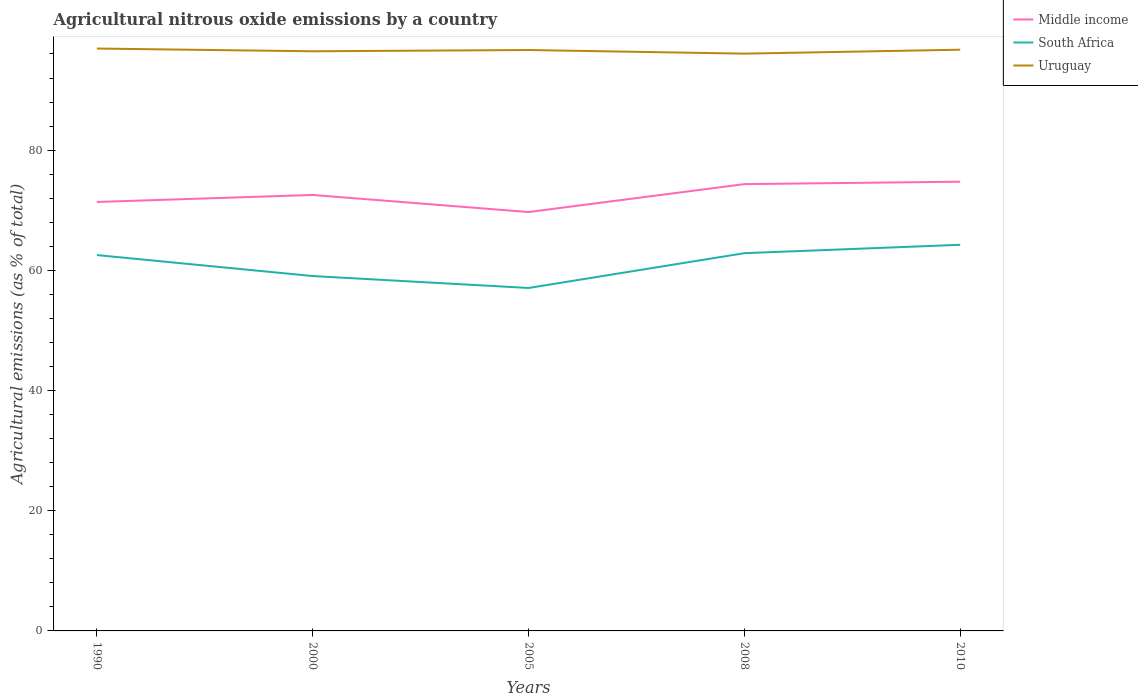Across all years, what is the maximum amount of agricultural nitrous oxide emitted in Uruguay?
Provide a succinct answer. 96.06. In which year was the amount of agricultural nitrous oxide emitted in Middle income maximum?
Give a very brief answer. 2005. What is the total amount of agricultural nitrous oxide emitted in Middle income in the graph?
Your answer should be compact. -4.64. What is the difference between the highest and the second highest amount of agricultural nitrous oxide emitted in Middle income?
Keep it short and to the point. 5.05. What is the difference between the highest and the lowest amount of agricultural nitrous oxide emitted in Uruguay?
Your response must be concise. 3. Is the amount of agricultural nitrous oxide emitted in Middle income strictly greater than the amount of agricultural nitrous oxide emitted in Uruguay over the years?
Offer a very short reply. Yes. How many lines are there?
Provide a succinct answer. 3. Are the values on the major ticks of Y-axis written in scientific E-notation?
Your answer should be very brief. No. Does the graph contain any zero values?
Give a very brief answer. No. Where does the legend appear in the graph?
Offer a terse response. Top right. How are the legend labels stacked?
Ensure brevity in your answer.  Vertical. What is the title of the graph?
Offer a terse response. Agricultural nitrous oxide emissions by a country. Does "Senegal" appear as one of the legend labels in the graph?
Give a very brief answer. No. What is the label or title of the X-axis?
Your response must be concise. Years. What is the label or title of the Y-axis?
Make the answer very short. Agricultural emissions (as % of total). What is the Agricultural emissions (as % of total) in Middle income in 1990?
Your answer should be compact. 71.38. What is the Agricultural emissions (as % of total) in South Africa in 1990?
Provide a succinct answer. 62.54. What is the Agricultural emissions (as % of total) in Uruguay in 1990?
Offer a very short reply. 96.91. What is the Agricultural emissions (as % of total) in Middle income in 2000?
Offer a terse response. 72.54. What is the Agricultural emissions (as % of total) of South Africa in 2000?
Make the answer very short. 59.05. What is the Agricultural emissions (as % of total) of Uruguay in 2000?
Keep it short and to the point. 96.45. What is the Agricultural emissions (as % of total) in Middle income in 2005?
Provide a short and direct response. 69.7. What is the Agricultural emissions (as % of total) of South Africa in 2005?
Offer a very short reply. 57.07. What is the Agricultural emissions (as % of total) in Uruguay in 2005?
Give a very brief answer. 96.66. What is the Agricultural emissions (as % of total) of Middle income in 2008?
Your response must be concise. 74.35. What is the Agricultural emissions (as % of total) in South Africa in 2008?
Your answer should be very brief. 62.86. What is the Agricultural emissions (as % of total) of Uruguay in 2008?
Offer a terse response. 96.06. What is the Agricultural emissions (as % of total) of Middle income in 2010?
Provide a short and direct response. 74.75. What is the Agricultural emissions (as % of total) of South Africa in 2010?
Keep it short and to the point. 64.25. What is the Agricultural emissions (as % of total) in Uruguay in 2010?
Your answer should be compact. 96.71. Across all years, what is the maximum Agricultural emissions (as % of total) of Middle income?
Offer a very short reply. 74.75. Across all years, what is the maximum Agricultural emissions (as % of total) in South Africa?
Offer a terse response. 64.25. Across all years, what is the maximum Agricultural emissions (as % of total) in Uruguay?
Your answer should be very brief. 96.91. Across all years, what is the minimum Agricultural emissions (as % of total) in Middle income?
Your answer should be compact. 69.7. Across all years, what is the minimum Agricultural emissions (as % of total) of South Africa?
Your answer should be compact. 57.07. Across all years, what is the minimum Agricultural emissions (as % of total) of Uruguay?
Your response must be concise. 96.06. What is the total Agricultural emissions (as % of total) of Middle income in the graph?
Ensure brevity in your answer.  362.72. What is the total Agricultural emissions (as % of total) in South Africa in the graph?
Make the answer very short. 305.76. What is the total Agricultural emissions (as % of total) of Uruguay in the graph?
Make the answer very short. 482.79. What is the difference between the Agricultural emissions (as % of total) in Middle income in 1990 and that in 2000?
Keep it short and to the point. -1.17. What is the difference between the Agricultural emissions (as % of total) of South Africa in 1990 and that in 2000?
Give a very brief answer. 3.49. What is the difference between the Agricultural emissions (as % of total) of Uruguay in 1990 and that in 2000?
Your answer should be compact. 0.46. What is the difference between the Agricultural emissions (as % of total) in Middle income in 1990 and that in 2005?
Provide a succinct answer. 1.68. What is the difference between the Agricultural emissions (as % of total) of South Africa in 1990 and that in 2005?
Offer a terse response. 5.48. What is the difference between the Agricultural emissions (as % of total) in Uruguay in 1990 and that in 2005?
Keep it short and to the point. 0.24. What is the difference between the Agricultural emissions (as % of total) in Middle income in 1990 and that in 2008?
Keep it short and to the point. -2.97. What is the difference between the Agricultural emissions (as % of total) of South Africa in 1990 and that in 2008?
Give a very brief answer. -0.32. What is the difference between the Agricultural emissions (as % of total) in Uruguay in 1990 and that in 2008?
Your response must be concise. 0.85. What is the difference between the Agricultural emissions (as % of total) of Middle income in 1990 and that in 2010?
Ensure brevity in your answer.  -3.37. What is the difference between the Agricultural emissions (as % of total) of South Africa in 1990 and that in 2010?
Keep it short and to the point. -1.71. What is the difference between the Agricultural emissions (as % of total) in Uruguay in 1990 and that in 2010?
Provide a short and direct response. 0.19. What is the difference between the Agricultural emissions (as % of total) of Middle income in 2000 and that in 2005?
Offer a terse response. 2.84. What is the difference between the Agricultural emissions (as % of total) in South Africa in 2000 and that in 2005?
Keep it short and to the point. 1.98. What is the difference between the Agricultural emissions (as % of total) of Uruguay in 2000 and that in 2005?
Your answer should be compact. -0.21. What is the difference between the Agricultural emissions (as % of total) in Middle income in 2000 and that in 2008?
Offer a very short reply. -1.8. What is the difference between the Agricultural emissions (as % of total) of South Africa in 2000 and that in 2008?
Your answer should be very brief. -3.81. What is the difference between the Agricultural emissions (as % of total) of Uruguay in 2000 and that in 2008?
Offer a terse response. 0.39. What is the difference between the Agricultural emissions (as % of total) of Middle income in 2000 and that in 2010?
Make the answer very short. -2.21. What is the difference between the Agricultural emissions (as % of total) in South Africa in 2000 and that in 2010?
Ensure brevity in your answer.  -5.2. What is the difference between the Agricultural emissions (as % of total) of Uruguay in 2000 and that in 2010?
Provide a succinct answer. -0.26. What is the difference between the Agricultural emissions (as % of total) in Middle income in 2005 and that in 2008?
Provide a succinct answer. -4.64. What is the difference between the Agricultural emissions (as % of total) of South Africa in 2005 and that in 2008?
Provide a short and direct response. -5.79. What is the difference between the Agricultural emissions (as % of total) of Uruguay in 2005 and that in 2008?
Your answer should be very brief. 0.6. What is the difference between the Agricultural emissions (as % of total) of Middle income in 2005 and that in 2010?
Offer a very short reply. -5.05. What is the difference between the Agricultural emissions (as % of total) in South Africa in 2005 and that in 2010?
Provide a succinct answer. -7.18. What is the difference between the Agricultural emissions (as % of total) in Uruguay in 2005 and that in 2010?
Your response must be concise. -0.05. What is the difference between the Agricultural emissions (as % of total) in Middle income in 2008 and that in 2010?
Provide a short and direct response. -0.4. What is the difference between the Agricultural emissions (as % of total) of South Africa in 2008 and that in 2010?
Give a very brief answer. -1.39. What is the difference between the Agricultural emissions (as % of total) of Uruguay in 2008 and that in 2010?
Provide a succinct answer. -0.65. What is the difference between the Agricultural emissions (as % of total) in Middle income in 1990 and the Agricultural emissions (as % of total) in South Africa in 2000?
Give a very brief answer. 12.33. What is the difference between the Agricultural emissions (as % of total) of Middle income in 1990 and the Agricultural emissions (as % of total) of Uruguay in 2000?
Your answer should be very brief. -25.07. What is the difference between the Agricultural emissions (as % of total) in South Africa in 1990 and the Agricultural emissions (as % of total) in Uruguay in 2000?
Make the answer very short. -33.91. What is the difference between the Agricultural emissions (as % of total) of Middle income in 1990 and the Agricultural emissions (as % of total) of South Africa in 2005?
Your answer should be compact. 14.31. What is the difference between the Agricultural emissions (as % of total) in Middle income in 1990 and the Agricultural emissions (as % of total) in Uruguay in 2005?
Offer a very short reply. -25.28. What is the difference between the Agricultural emissions (as % of total) of South Africa in 1990 and the Agricultural emissions (as % of total) of Uruguay in 2005?
Offer a terse response. -34.12. What is the difference between the Agricultural emissions (as % of total) in Middle income in 1990 and the Agricultural emissions (as % of total) in South Africa in 2008?
Provide a succinct answer. 8.52. What is the difference between the Agricultural emissions (as % of total) in Middle income in 1990 and the Agricultural emissions (as % of total) in Uruguay in 2008?
Keep it short and to the point. -24.68. What is the difference between the Agricultural emissions (as % of total) of South Africa in 1990 and the Agricultural emissions (as % of total) of Uruguay in 2008?
Your response must be concise. -33.52. What is the difference between the Agricultural emissions (as % of total) of Middle income in 1990 and the Agricultural emissions (as % of total) of South Africa in 2010?
Offer a very short reply. 7.13. What is the difference between the Agricultural emissions (as % of total) of Middle income in 1990 and the Agricultural emissions (as % of total) of Uruguay in 2010?
Ensure brevity in your answer.  -25.34. What is the difference between the Agricultural emissions (as % of total) of South Africa in 1990 and the Agricultural emissions (as % of total) of Uruguay in 2010?
Make the answer very short. -34.17. What is the difference between the Agricultural emissions (as % of total) in Middle income in 2000 and the Agricultural emissions (as % of total) in South Africa in 2005?
Your response must be concise. 15.48. What is the difference between the Agricultural emissions (as % of total) in Middle income in 2000 and the Agricultural emissions (as % of total) in Uruguay in 2005?
Offer a terse response. -24.12. What is the difference between the Agricultural emissions (as % of total) in South Africa in 2000 and the Agricultural emissions (as % of total) in Uruguay in 2005?
Provide a succinct answer. -37.61. What is the difference between the Agricultural emissions (as % of total) of Middle income in 2000 and the Agricultural emissions (as % of total) of South Africa in 2008?
Give a very brief answer. 9.69. What is the difference between the Agricultural emissions (as % of total) in Middle income in 2000 and the Agricultural emissions (as % of total) in Uruguay in 2008?
Provide a succinct answer. -23.51. What is the difference between the Agricultural emissions (as % of total) of South Africa in 2000 and the Agricultural emissions (as % of total) of Uruguay in 2008?
Your answer should be very brief. -37.01. What is the difference between the Agricultural emissions (as % of total) in Middle income in 2000 and the Agricultural emissions (as % of total) in South Africa in 2010?
Keep it short and to the point. 8.29. What is the difference between the Agricultural emissions (as % of total) of Middle income in 2000 and the Agricultural emissions (as % of total) of Uruguay in 2010?
Provide a succinct answer. -24.17. What is the difference between the Agricultural emissions (as % of total) in South Africa in 2000 and the Agricultural emissions (as % of total) in Uruguay in 2010?
Your response must be concise. -37.66. What is the difference between the Agricultural emissions (as % of total) of Middle income in 2005 and the Agricultural emissions (as % of total) of South Africa in 2008?
Keep it short and to the point. 6.84. What is the difference between the Agricultural emissions (as % of total) of Middle income in 2005 and the Agricultural emissions (as % of total) of Uruguay in 2008?
Your answer should be very brief. -26.36. What is the difference between the Agricultural emissions (as % of total) of South Africa in 2005 and the Agricultural emissions (as % of total) of Uruguay in 2008?
Your response must be concise. -38.99. What is the difference between the Agricultural emissions (as % of total) in Middle income in 2005 and the Agricultural emissions (as % of total) in South Africa in 2010?
Provide a succinct answer. 5.45. What is the difference between the Agricultural emissions (as % of total) in Middle income in 2005 and the Agricultural emissions (as % of total) in Uruguay in 2010?
Provide a succinct answer. -27.01. What is the difference between the Agricultural emissions (as % of total) in South Africa in 2005 and the Agricultural emissions (as % of total) in Uruguay in 2010?
Your answer should be compact. -39.65. What is the difference between the Agricultural emissions (as % of total) in Middle income in 2008 and the Agricultural emissions (as % of total) in South Africa in 2010?
Your answer should be compact. 10.1. What is the difference between the Agricultural emissions (as % of total) in Middle income in 2008 and the Agricultural emissions (as % of total) in Uruguay in 2010?
Your answer should be compact. -22.37. What is the difference between the Agricultural emissions (as % of total) in South Africa in 2008 and the Agricultural emissions (as % of total) in Uruguay in 2010?
Ensure brevity in your answer.  -33.86. What is the average Agricultural emissions (as % of total) in Middle income per year?
Your response must be concise. 72.54. What is the average Agricultural emissions (as % of total) of South Africa per year?
Your response must be concise. 61.15. What is the average Agricultural emissions (as % of total) in Uruguay per year?
Your answer should be compact. 96.56. In the year 1990, what is the difference between the Agricultural emissions (as % of total) of Middle income and Agricultural emissions (as % of total) of South Africa?
Offer a terse response. 8.84. In the year 1990, what is the difference between the Agricultural emissions (as % of total) in Middle income and Agricultural emissions (as % of total) in Uruguay?
Provide a short and direct response. -25.53. In the year 1990, what is the difference between the Agricultural emissions (as % of total) in South Africa and Agricultural emissions (as % of total) in Uruguay?
Provide a succinct answer. -34.37. In the year 2000, what is the difference between the Agricultural emissions (as % of total) of Middle income and Agricultural emissions (as % of total) of South Africa?
Offer a terse response. 13.49. In the year 2000, what is the difference between the Agricultural emissions (as % of total) in Middle income and Agricultural emissions (as % of total) in Uruguay?
Keep it short and to the point. -23.91. In the year 2000, what is the difference between the Agricultural emissions (as % of total) of South Africa and Agricultural emissions (as % of total) of Uruguay?
Offer a very short reply. -37.4. In the year 2005, what is the difference between the Agricultural emissions (as % of total) of Middle income and Agricultural emissions (as % of total) of South Africa?
Ensure brevity in your answer.  12.64. In the year 2005, what is the difference between the Agricultural emissions (as % of total) in Middle income and Agricultural emissions (as % of total) in Uruguay?
Offer a terse response. -26.96. In the year 2005, what is the difference between the Agricultural emissions (as % of total) in South Africa and Agricultural emissions (as % of total) in Uruguay?
Make the answer very short. -39.6. In the year 2008, what is the difference between the Agricultural emissions (as % of total) in Middle income and Agricultural emissions (as % of total) in South Africa?
Ensure brevity in your answer.  11.49. In the year 2008, what is the difference between the Agricultural emissions (as % of total) of Middle income and Agricultural emissions (as % of total) of Uruguay?
Your answer should be very brief. -21.71. In the year 2008, what is the difference between the Agricultural emissions (as % of total) in South Africa and Agricultural emissions (as % of total) in Uruguay?
Offer a terse response. -33.2. In the year 2010, what is the difference between the Agricultural emissions (as % of total) of Middle income and Agricultural emissions (as % of total) of South Africa?
Your answer should be compact. 10.5. In the year 2010, what is the difference between the Agricultural emissions (as % of total) in Middle income and Agricultural emissions (as % of total) in Uruguay?
Give a very brief answer. -21.96. In the year 2010, what is the difference between the Agricultural emissions (as % of total) in South Africa and Agricultural emissions (as % of total) in Uruguay?
Ensure brevity in your answer.  -32.46. What is the ratio of the Agricultural emissions (as % of total) of Middle income in 1990 to that in 2000?
Offer a terse response. 0.98. What is the ratio of the Agricultural emissions (as % of total) in South Africa in 1990 to that in 2000?
Your answer should be very brief. 1.06. What is the ratio of the Agricultural emissions (as % of total) in Middle income in 1990 to that in 2005?
Keep it short and to the point. 1.02. What is the ratio of the Agricultural emissions (as % of total) of South Africa in 1990 to that in 2005?
Your answer should be very brief. 1.1. What is the ratio of the Agricultural emissions (as % of total) in Middle income in 1990 to that in 2008?
Provide a succinct answer. 0.96. What is the ratio of the Agricultural emissions (as % of total) in South Africa in 1990 to that in 2008?
Offer a terse response. 0.99. What is the ratio of the Agricultural emissions (as % of total) in Uruguay in 1990 to that in 2008?
Your response must be concise. 1.01. What is the ratio of the Agricultural emissions (as % of total) of Middle income in 1990 to that in 2010?
Provide a short and direct response. 0.95. What is the ratio of the Agricultural emissions (as % of total) of South Africa in 1990 to that in 2010?
Offer a very short reply. 0.97. What is the ratio of the Agricultural emissions (as % of total) of Middle income in 2000 to that in 2005?
Provide a short and direct response. 1.04. What is the ratio of the Agricultural emissions (as % of total) in South Africa in 2000 to that in 2005?
Offer a very short reply. 1.03. What is the ratio of the Agricultural emissions (as % of total) of Uruguay in 2000 to that in 2005?
Keep it short and to the point. 1. What is the ratio of the Agricultural emissions (as % of total) in Middle income in 2000 to that in 2008?
Your answer should be compact. 0.98. What is the ratio of the Agricultural emissions (as % of total) in South Africa in 2000 to that in 2008?
Offer a terse response. 0.94. What is the ratio of the Agricultural emissions (as % of total) of Middle income in 2000 to that in 2010?
Offer a terse response. 0.97. What is the ratio of the Agricultural emissions (as % of total) in South Africa in 2000 to that in 2010?
Offer a very short reply. 0.92. What is the ratio of the Agricultural emissions (as % of total) in Uruguay in 2000 to that in 2010?
Keep it short and to the point. 1. What is the ratio of the Agricultural emissions (as % of total) of Middle income in 2005 to that in 2008?
Offer a terse response. 0.94. What is the ratio of the Agricultural emissions (as % of total) in South Africa in 2005 to that in 2008?
Your answer should be compact. 0.91. What is the ratio of the Agricultural emissions (as % of total) of Middle income in 2005 to that in 2010?
Your answer should be very brief. 0.93. What is the ratio of the Agricultural emissions (as % of total) in South Africa in 2005 to that in 2010?
Your answer should be compact. 0.89. What is the ratio of the Agricultural emissions (as % of total) of South Africa in 2008 to that in 2010?
Your answer should be compact. 0.98. What is the difference between the highest and the second highest Agricultural emissions (as % of total) in Middle income?
Make the answer very short. 0.4. What is the difference between the highest and the second highest Agricultural emissions (as % of total) of South Africa?
Offer a very short reply. 1.39. What is the difference between the highest and the second highest Agricultural emissions (as % of total) of Uruguay?
Your answer should be very brief. 0.19. What is the difference between the highest and the lowest Agricultural emissions (as % of total) in Middle income?
Keep it short and to the point. 5.05. What is the difference between the highest and the lowest Agricultural emissions (as % of total) in South Africa?
Offer a terse response. 7.18. What is the difference between the highest and the lowest Agricultural emissions (as % of total) in Uruguay?
Ensure brevity in your answer.  0.85. 